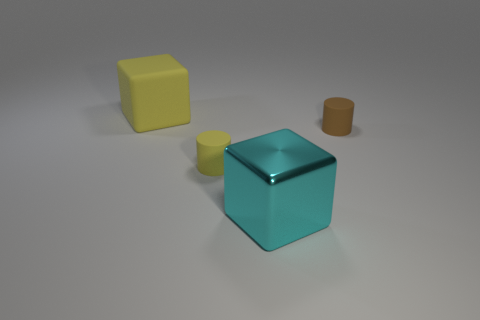Is the number of cubes that are in front of the big cyan shiny block less than the number of tiny brown objects that are left of the rubber cube?
Your answer should be very brief. No. There is another thing that is the same shape as the big matte object; what is its color?
Offer a very short reply. Cyan. There is a object behind the brown cylinder; is it the same size as the brown rubber thing?
Your answer should be compact. No. Is the number of large yellow matte things on the right side of the large shiny thing less than the number of yellow matte cylinders?
Your answer should be very brief. Yes. Is there anything else that is the same size as the cyan metal thing?
Provide a short and direct response. Yes. What size is the block to the right of the big object behind the large cyan metallic object?
Provide a short and direct response. Large. Is there any other thing that has the same shape as the big cyan thing?
Your answer should be compact. Yes. Are there fewer large yellow rubber objects than blue rubber objects?
Make the answer very short. No. There is a thing that is on the right side of the large yellow object and behind the small yellow thing; what material is it?
Provide a short and direct response. Rubber. There is a yellow thing that is to the right of the big yellow rubber cube; are there any cyan metallic objects behind it?
Your answer should be compact. No. 